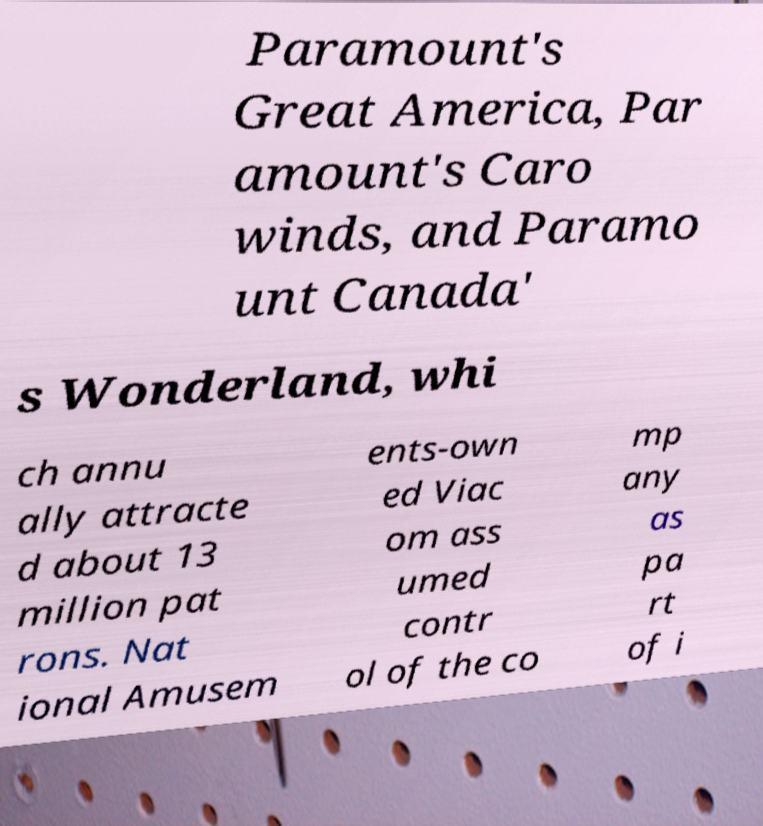Please identify and transcribe the text found in this image. Paramount's Great America, Par amount's Caro winds, and Paramo unt Canada' s Wonderland, whi ch annu ally attracte d about 13 million pat rons. Nat ional Amusem ents-own ed Viac om ass umed contr ol of the co mp any as pa rt of i 